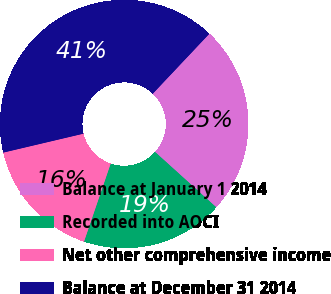Convert chart. <chart><loc_0><loc_0><loc_500><loc_500><pie_chart><fcel>Balance at January 1 2014<fcel>Recorded into AOCI<fcel>Net other comprehensive income<fcel>Balance at December 31 2014<nl><fcel>24.66%<fcel>18.54%<fcel>16.07%<fcel>40.73%<nl></chart> 